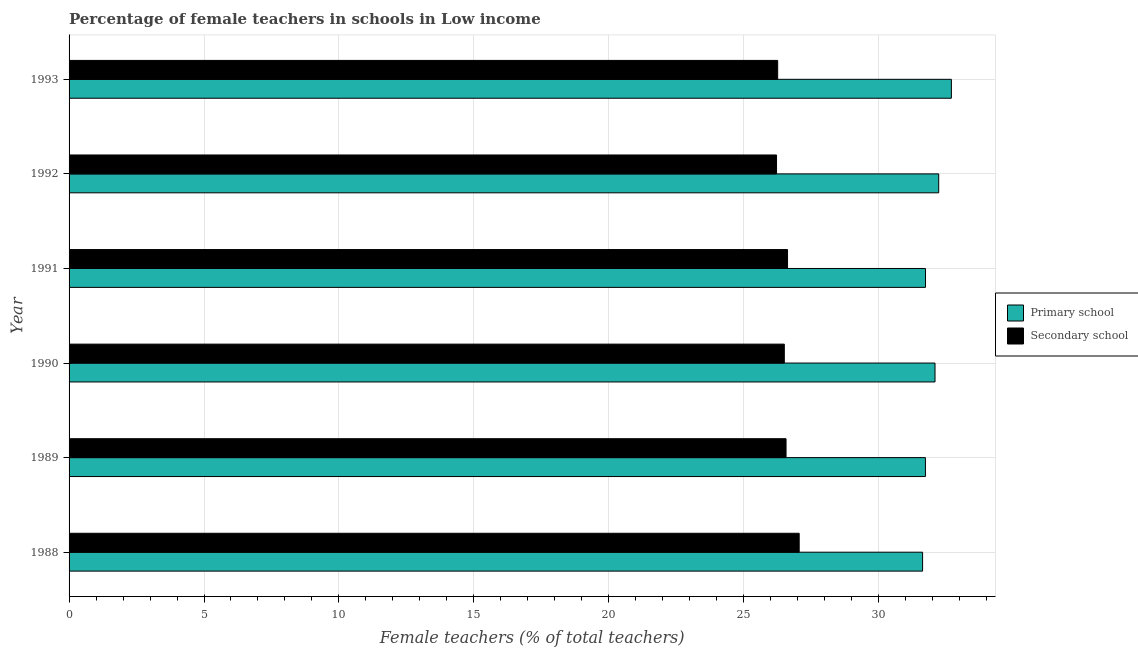How many different coloured bars are there?
Offer a terse response. 2. How many groups of bars are there?
Make the answer very short. 6. Are the number of bars on each tick of the Y-axis equal?
Ensure brevity in your answer.  Yes. How many bars are there on the 2nd tick from the top?
Your answer should be compact. 2. In how many cases, is the number of bars for a given year not equal to the number of legend labels?
Provide a short and direct response. 0. What is the percentage of female teachers in primary schools in 1990?
Keep it short and to the point. 32.09. Across all years, what is the maximum percentage of female teachers in secondary schools?
Keep it short and to the point. 27.06. Across all years, what is the minimum percentage of female teachers in primary schools?
Offer a very short reply. 31.63. What is the total percentage of female teachers in secondary schools in the graph?
Make the answer very short. 159.23. What is the difference between the percentage of female teachers in primary schools in 1990 and that in 1991?
Offer a terse response. 0.35. What is the difference between the percentage of female teachers in primary schools in 1991 and the percentage of female teachers in secondary schools in 1990?
Your response must be concise. 5.23. What is the average percentage of female teachers in secondary schools per year?
Provide a succinct answer. 26.54. In the year 1988, what is the difference between the percentage of female teachers in primary schools and percentage of female teachers in secondary schools?
Offer a very short reply. 4.57. Is the percentage of female teachers in secondary schools in 1991 less than that in 1993?
Keep it short and to the point. No. Is the difference between the percentage of female teachers in secondary schools in 1988 and 1990 greater than the difference between the percentage of female teachers in primary schools in 1988 and 1990?
Ensure brevity in your answer.  Yes. What is the difference between the highest and the second highest percentage of female teachers in primary schools?
Provide a short and direct response. 0.47. What is the difference between the highest and the lowest percentage of female teachers in primary schools?
Keep it short and to the point. 1.07. Is the sum of the percentage of female teachers in secondary schools in 1989 and 1991 greater than the maximum percentage of female teachers in primary schools across all years?
Ensure brevity in your answer.  Yes. What does the 2nd bar from the top in 1993 represents?
Give a very brief answer. Primary school. What does the 1st bar from the bottom in 1990 represents?
Give a very brief answer. Primary school. How many bars are there?
Ensure brevity in your answer.  12. Are all the bars in the graph horizontal?
Keep it short and to the point. Yes. How many years are there in the graph?
Your answer should be very brief. 6. What is the difference between two consecutive major ticks on the X-axis?
Keep it short and to the point. 5. What is the title of the graph?
Your answer should be very brief. Percentage of female teachers in schools in Low income. Does "IMF concessional" appear as one of the legend labels in the graph?
Provide a short and direct response. No. What is the label or title of the X-axis?
Offer a terse response. Female teachers (% of total teachers). What is the Female teachers (% of total teachers) in Primary school in 1988?
Provide a short and direct response. 31.63. What is the Female teachers (% of total teachers) of Secondary school in 1988?
Your answer should be very brief. 27.06. What is the Female teachers (% of total teachers) of Primary school in 1989?
Offer a very short reply. 31.73. What is the Female teachers (% of total teachers) of Secondary school in 1989?
Make the answer very short. 26.57. What is the Female teachers (% of total teachers) of Primary school in 1990?
Keep it short and to the point. 32.09. What is the Female teachers (% of total teachers) in Secondary school in 1990?
Provide a succinct answer. 26.5. What is the Female teachers (% of total teachers) of Primary school in 1991?
Your response must be concise. 31.74. What is the Female teachers (% of total teachers) of Secondary school in 1991?
Keep it short and to the point. 26.62. What is the Female teachers (% of total teachers) in Primary school in 1992?
Offer a very short reply. 32.23. What is the Female teachers (% of total teachers) in Secondary school in 1992?
Give a very brief answer. 26.22. What is the Female teachers (% of total teachers) of Primary school in 1993?
Ensure brevity in your answer.  32.7. What is the Female teachers (% of total teachers) of Secondary school in 1993?
Your answer should be very brief. 26.26. Across all years, what is the maximum Female teachers (% of total teachers) of Primary school?
Give a very brief answer. 32.7. Across all years, what is the maximum Female teachers (% of total teachers) of Secondary school?
Ensure brevity in your answer.  27.06. Across all years, what is the minimum Female teachers (% of total teachers) of Primary school?
Ensure brevity in your answer.  31.63. Across all years, what is the minimum Female teachers (% of total teachers) of Secondary school?
Provide a succinct answer. 26.22. What is the total Female teachers (% of total teachers) of Primary school in the graph?
Keep it short and to the point. 192.11. What is the total Female teachers (% of total teachers) in Secondary school in the graph?
Your answer should be very brief. 159.23. What is the difference between the Female teachers (% of total teachers) of Primary school in 1988 and that in 1989?
Ensure brevity in your answer.  -0.11. What is the difference between the Female teachers (% of total teachers) in Secondary school in 1988 and that in 1989?
Make the answer very short. 0.49. What is the difference between the Female teachers (% of total teachers) in Primary school in 1988 and that in 1990?
Your answer should be compact. -0.46. What is the difference between the Female teachers (% of total teachers) in Secondary school in 1988 and that in 1990?
Provide a succinct answer. 0.55. What is the difference between the Female teachers (% of total teachers) of Primary school in 1988 and that in 1991?
Offer a very short reply. -0.11. What is the difference between the Female teachers (% of total teachers) of Secondary school in 1988 and that in 1991?
Your response must be concise. 0.43. What is the difference between the Female teachers (% of total teachers) in Primary school in 1988 and that in 1992?
Give a very brief answer. -0.6. What is the difference between the Female teachers (% of total teachers) of Secondary school in 1988 and that in 1992?
Your answer should be compact. 0.84. What is the difference between the Female teachers (% of total teachers) of Primary school in 1988 and that in 1993?
Ensure brevity in your answer.  -1.07. What is the difference between the Female teachers (% of total teachers) in Secondary school in 1988 and that in 1993?
Your answer should be very brief. 0.8. What is the difference between the Female teachers (% of total teachers) in Primary school in 1989 and that in 1990?
Your response must be concise. -0.36. What is the difference between the Female teachers (% of total teachers) in Secondary school in 1989 and that in 1990?
Keep it short and to the point. 0.06. What is the difference between the Female teachers (% of total teachers) of Primary school in 1989 and that in 1991?
Offer a terse response. -0. What is the difference between the Female teachers (% of total teachers) of Secondary school in 1989 and that in 1991?
Provide a short and direct response. -0.06. What is the difference between the Female teachers (% of total teachers) of Primary school in 1989 and that in 1992?
Give a very brief answer. -0.49. What is the difference between the Female teachers (% of total teachers) of Secondary school in 1989 and that in 1992?
Keep it short and to the point. 0.35. What is the difference between the Female teachers (% of total teachers) of Primary school in 1989 and that in 1993?
Offer a very short reply. -0.96. What is the difference between the Female teachers (% of total teachers) of Secondary school in 1989 and that in 1993?
Your answer should be very brief. 0.31. What is the difference between the Female teachers (% of total teachers) in Primary school in 1990 and that in 1991?
Give a very brief answer. 0.35. What is the difference between the Female teachers (% of total teachers) of Secondary school in 1990 and that in 1991?
Your response must be concise. -0.12. What is the difference between the Female teachers (% of total teachers) in Primary school in 1990 and that in 1992?
Give a very brief answer. -0.14. What is the difference between the Female teachers (% of total teachers) of Secondary school in 1990 and that in 1992?
Keep it short and to the point. 0.29. What is the difference between the Female teachers (% of total teachers) of Primary school in 1990 and that in 1993?
Offer a very short reply. -0.61. What is the difference between the Female teachers (% of total teachers) of Secondary school in 1990 and that in 1993?
Offer a very short reply. 0.25. What is the difference between the Female teachers (% of total teachers) in Primary school in 1991 and that in 1992?
Provide a succinct answer. -0.49. What is the difference between the Female teachers (% of total teachers) in Secondary school in 1991 and that in 1992?
Your response must be concise. 0.41. What is the difference between the Female teachers (% of total teachers) in Primary school in 1991 and that in 1993?
Offer a very short reply. -0.96. What is the difference between the Female teachers (% of total teachers) in Secondary school in 1991 and that in 1993?
Offer a terse response. 0.37. What is the difference between the Female teachers (% of total teachers) of Primary school in 1992 and that in 1993?
Offer a very short reply. -0.47. What is the difference between the Female teachers (% of total teachers) of Secondary school in 1992 and that in 1993?
Your answer should be very brief. -0.04. What is the difference between the Female teachers (% of total teachers) in Primary school in 1988 and the Female teachers (% of total teachers) in Secondary school in 1989?
Ensure brevity in your answer.  5.06. What is the difference between the Female teachers (% of total teachers) in Primary school in 1988 and the Female teachers (% of total teachers) in Secondary school in 1990?
Give a very brief answer. 5.12. What is the difference between the Female teachers (% of total teachers) in Primary school in 1988 and the Female teachers (% of total teachers) in Secondary school in 1991?
Ensure brevity in your answer.  5. What is the difference between the Female teachers (% of total teachers) in Primary school in 1988 and the Female teachers (% of total teachers) in Secondary school in 1992?
Provide a short and direct response. 5.41. What is the difference between the Female teachers (% of total teachers) in Primary school in 1988 and the Female teachers (% of total teachers) in Secondary school in 1993?
Your response must be concise. 5.37. What is the difference between the Female teachers (% of total teachers) in Primary school in 1989 and the Female teachers (% of total teachers) in Secondary school in 1990?
Your response must be concise. 5.23. What is the difference between the Female teachers (% of total teachers) of Primary school in 1989 and the Female teachers (% of total teachers) of Secondary school in 1991?
Keep it short and to the point. 5.11. What is the difference between the Female teachers (% of total teachers) of Primary school in 1989 and the Female teachers (% of total teachers) of Secondary school in 1992?
Provide a succinct answer. 5.52. What is the difference between the Female teachers (% of total teachers) in Primary school in 1989 and the Female teachers (% of total teachers) in Secondary school in 1993?
Ensure brevity in your answer.  5.48. What is the difference between the Female teachers (% of total teachers) in Primary school in 1990 and the Female teachers (% of total teachers) in Secondary school in 1991?
Ensure brevity in your answer.  5.46. What is the difference between the Female teachers (% of total teachers) of Primary school in 1990 and the Female teachers (% of total teachers) of Secondary school in 1992?
Offer a very short reply. 5.87. What is the difference between the Female teachers (% of total teachers) of Primary school in 1990 and the Female teachers (% of total teachers) of Secondary school in 1993?
Keep it short and to the point. 5.83. What is the difference between the Female teachers (% of total teachers) of Primary school in 1991 and the Female teachers (% of total teachers) of Secondary school in 1992?
Your answer should be compact. 5.52. What is the difference between the Female teachers (% of total teachers) of Primary school in 1991 and the Female teachers (% of total teachers) of Secondary school in 1993?
Provide a succinct answer. 5.48. What is the difference between the Female teachers (% of total teachers) in Primary school in 1992 and the Female teachers (% of total teachers) in Secondary school in 1993?
Provide a succinct answer. 5.97. What is the average Female teachers (% of total teachers) in Primary school per year?
Make the answer very short. 32.02. What is the average Female teachers (% of total teachers) in Secondary school per year?
Offer a very short reply. 26.54. In the year 1988, what is the difference between the Female teachers (% of total teachers) in Primary school and Female teachers (% of total teachers) in Secondary school?
Provide a short and direct response. 4.57. In the year 1989, what is the difference between the Female teachers (% of total teachers) in Primary school and Female teachers (% of total teachers) in Secondary school?
Ensure brevity in your answer.  5.17. In the year 1990, what is the difference between the Female teachers (% of total teachers) of Primary school and Female teachers (% of total teachers) of Secondary school?
Offer a very short reply. 5.58. In the year 1991, what is the difference between the Female teachers (% of total teachers) in Primary school and Female teachers (% of total teachers) in Secondary school?
Give a very brief answer. 5.11. In the year 1992, what is the difference between the Female teachers (% of total teachers) of Primary school and Female teachers (% of total teachers) of Secondary school?
Ensure brevity in your answer.  6.01. In the year 1993, what is the difference between the Female teachers (% of total teachers) of Primary school and Female teachers (% of total teachers) of Secondary school?
Your response must be concise. 6.44. What is the ratio of the Female teachers (% of total teachers) in Primary school in 1988 to that in 1989?
Provide a succinct answer. 1. What is the ratio of the Female teachers (% of total teachers) of Secondary school in 1988 to that in 1989?
Your answer should be very brief. 1.02. What is the ratio of the Female teachers (% of total teachers) of Primary school in 1988 to that in 1990?
Make the answer very short. 0.99. What is the ratio of the Female teachers (% of total teachers) of Secondary school in 1988 to that in 1990?
Give a very brief answer. 1.02. What is the ratio of the Female teachers (% of total teachers) in Primary school in 1988 to that in 1991?
Keep it short and to the point. 1. What is the ratio of the Female teachers (% of total teachers) in Secondary school in 1988 to that in 1991?
Offer a terse response. 1.02. What is the ratio of the Female teachers (% of total teachers) in Primary school in 1988 to that in 1992?
Provide a short and direct response. 0.98. What is the ratio of the Female teachers (% of total teachers) in Secondary school in 1988 to that in 1992?
Provide a short and direct response. 1.03. What is the ratio of the Female teachers (% of total teachers) of Primary school in 1988 to that in 1993?
Keep it short and to the point. 0.97. What is the ratio of the Female teachers (% of total teachers) in Secondary school in 1988 to that in 1993?
Your response must be concise. 1.03. What is the ratio of the Female teachers (% of total teachers) of Primary school in 1989 to that in 1990?
Give a very brief answer. 0.99. What is the ratio of the Female teachers (% of total teachers) of Primary school in 1989 to that in 1991?
Give a very brief answer. 1. What is the ratio of the Female teachers (% of total teachers) in Secondary school in 1989 to that in 1991?
Keep it short and to the point. 1. What is the ratio of the Female teachers (% of total teachers) in Primary school in 1989 to that in 1992?
Your answer should be compact. 0.98. What is the ratio of the Female teachers (% of total teachers) of Secondary school in 1989 to that in 1992?
Give a very brief answer. 1.01. What is the ratio of the Female teachers (% of total teachers) of Primary school in 1989 to that in 1993?
Your answer should be very brief. 0.97. What is the ratio of the Female teachers (% of total teachers) in Secondary school in 1989 to that in 1993?
Ensure brevity in your answer.  1.01. What is the ratio of the Female teachers (% of total teachers) in Primary school in 1990 to that in 1991?
Offer a very short reply. 1.01. What is the ratio of the Female teachers (% of total teachers) of Secondary school in 1990 to that in 1991?
Provide a succinct answer. 1. What is the ratio of the Female teachers (% of total teachers) of Primary school in 1990 to that in 1992?
Your answer should be compact. 1. What is the ratio of the Female teachers (% of total teachers) of Primary school in 1990 to that in 1993?
Offer a very short reply. 0.98. What is the ratio of the Female teachers (% of total teachers) of Secondary school in 1990 to that in 1993?
Offer a very short reply. 1.01. What is the ratio of the Female teachers (% of total teachers) in Secondary school in 1991 to that in 1992?
Make the answer very short. 1.02. What is the ratio of the Female teachers (% of total teachers) of Primary school in 1991 to that in 1993?
Keep it short and to the point. 0.97. What is the ratio of the Female teachers (% of total teachers) of Secondary school in 1991 to that in 1993?
Your answer should be very brief. 1.01. What is the ratio of the Female teachers (% of total teachers) in Primary school in 1992 to that in 1993?
Offer a terse response. 0.99. What is the difference between the highest and the second highest Female teachers (% of total teachers) in Primary school?
Ensure brevity in your answer.  0.47. What is the difference between the highest and the second highest Female teachers (% of total teachers) in Secondary school?
Provide a succinct answer. 0.43. What is the difference between the highest and the lowest Female teachers (% of total teachers) of Primary school?
Ensure brevity in your answer.  1.07. What is the difference between the highest and the lowest Female teachers (% of total teachers) in Secondary school?
Keep it short and to the point. 0.84. 